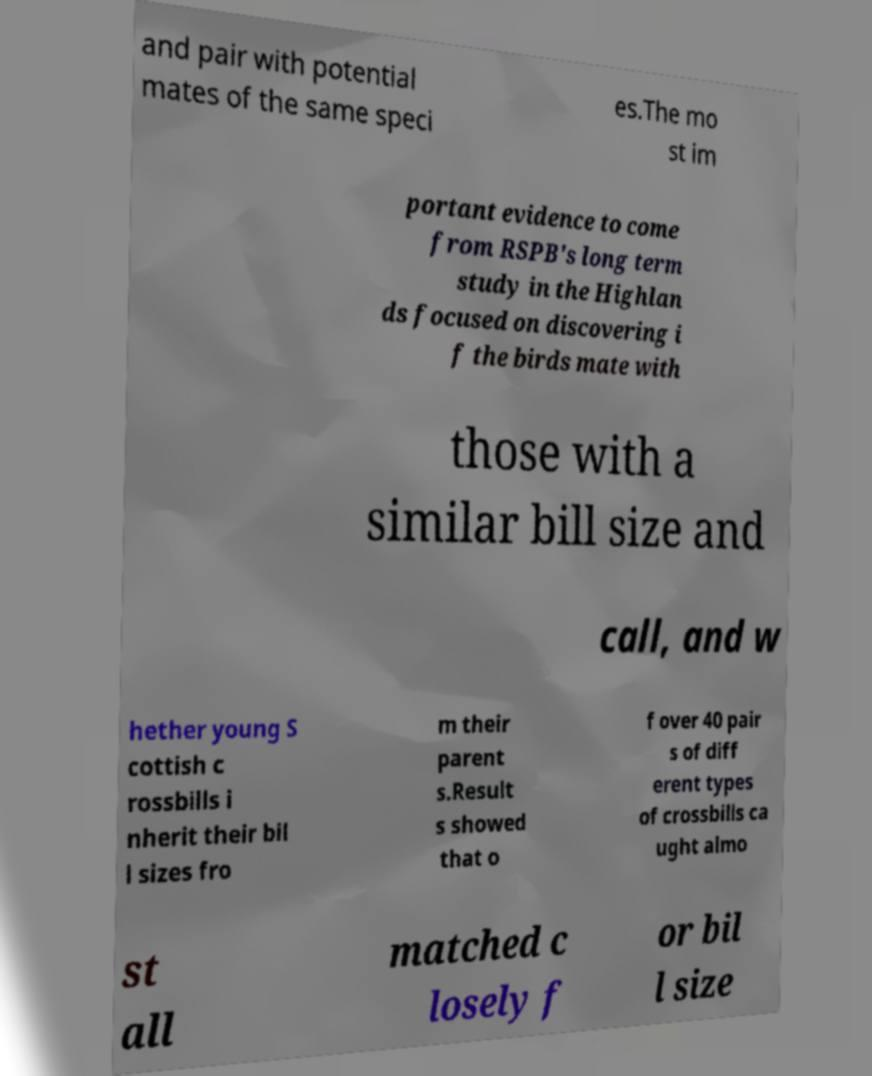Could you extract and type out the text from this image? and pair with potential mates of the same speci es.The mo st im portant evidence to come from RSPB's long term study in the Highlan ds focused on discovering i f the birds mate with those with a similar bill size and call, and w hether young S cottish c rossbills i nherit their bil l sizes fro m their parent s.Result s showed that o f over 40 pair s of diff erent types of crossbills ca ught almo st all matched c losely f or bil l size 